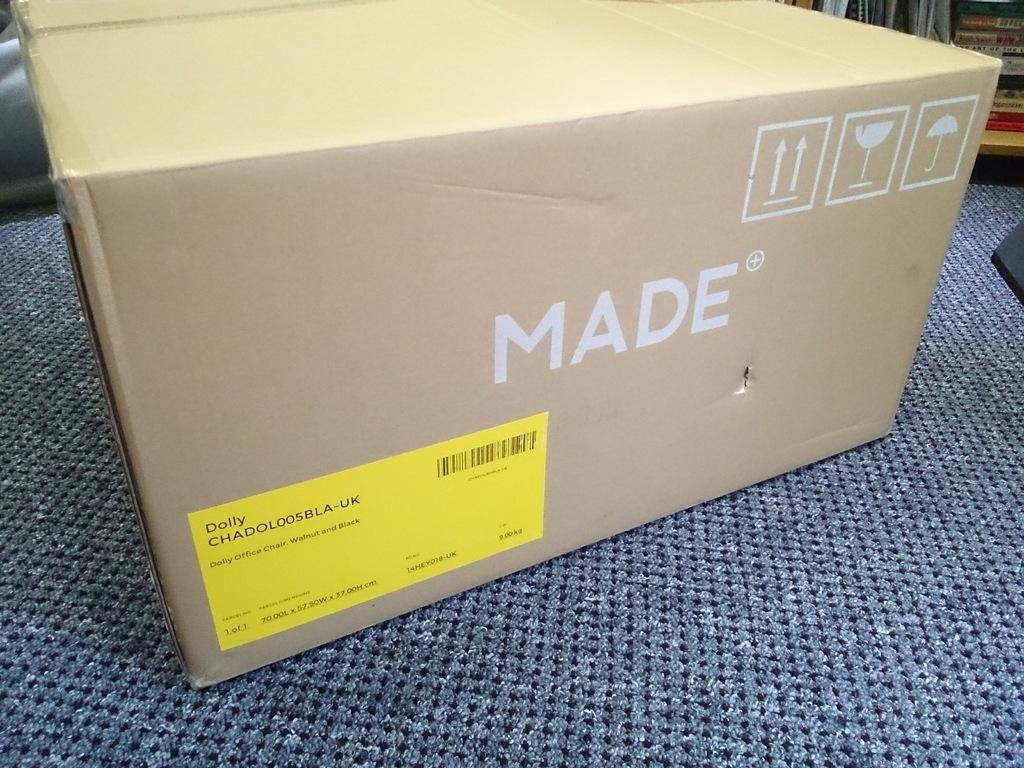<image>
Summarize the visual content of the image. A cardboard box with the brand name "Made" on it. 